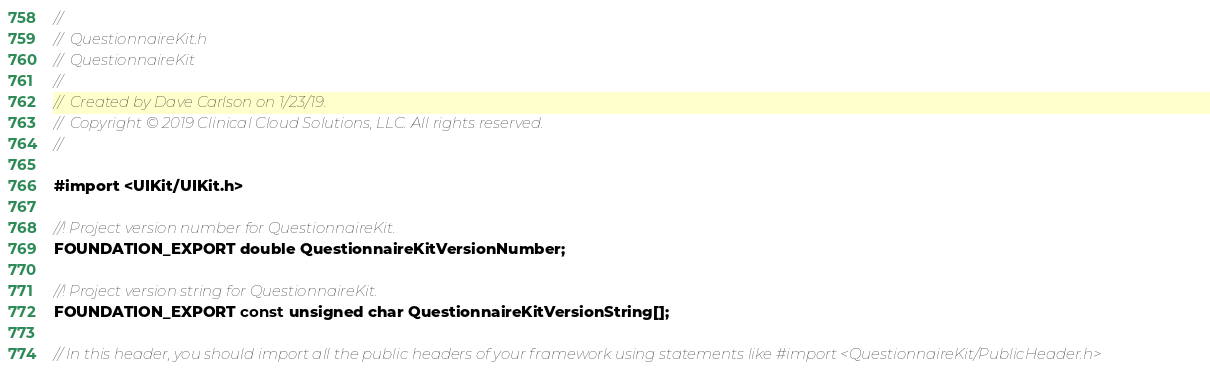<code> <loc_0><loc_0><loc_500><loc_500><_C_>//
//  QuestionnaireKit.h
//  QuestionnaireKit
//
//  Created by Dave Carlson on 1/23/19.
//  Copyright © 2019 Clinical Cloud Solutions, LLC. All rights reserved.
//

#import <UIKit/UIKit.h>

//! Project version number for QuestionnaireKit.
FOUNDATION_EXPORT double QuestionnaireKitVersionNumber;

//! Project version string for QuestionnaireKit.
FOUNDATION_EXPORT const unsigned char QuestionnaireKitVersionString[];

// In this header, you should import all the public headers of your framework using statements like #import <QuestionnaireKit/PublicHeader.h>


</code> 